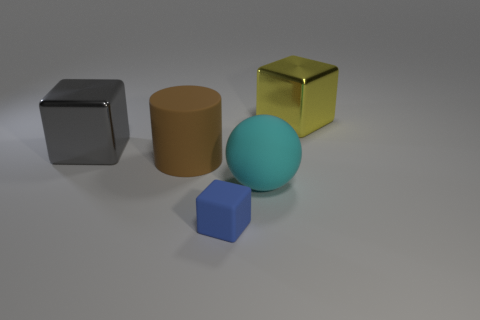There is a shiny block that is in front of the metal cube right of the metallic block that is in front of the yellow metallic block; how big is it?
Give a very brief answer. Large. Is the number of big yellow shiny blocks on the left side of the brown matte cylinder less than the number of big balls in front of the big cyan object?
Make the answer very short. No. How many large green cylinders have the same material as the large brown cylinder?
Your response must be concise. 0. Is there a brown rubber object that is on the right side of the block that is behind the big metal block in front of the yellow object?
Your response must be concise. No. There is a blue thing that is the same material as the cylinder; what is its shape?
Make the answer very short. Cube. Is the number of yellow rubber objects greater than the number of large gray metal cubes?
Your answer should be very brief. No. Is the shape of the big brown matte thing the same as the big metallic thing that is on the left side of the tiny blue rubber object?
Make the answer very short. No. What is the material of the yellow thing?
Provide a succinct answer. Metal. What is the color of the metal block in front of the shiny block on the right side of the metal cube that is left of the big yellow thing?
Provide a short and direct response. Gray. There is another gray thing that is the same shape as the tiny object; what is its material?
Keep it short and to the point. Metal. 